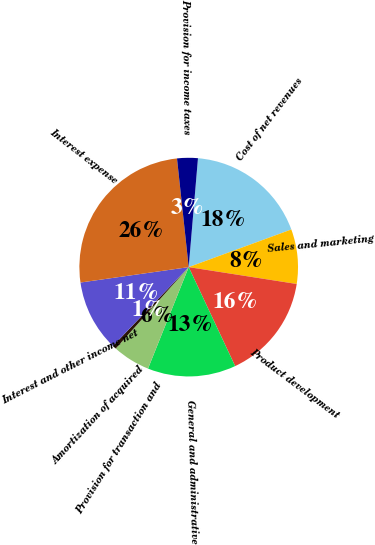<chart> <loc_0><loc_0><loc_500><loc_500><pie_chart><fcel>Cost of net revenues<fcel>Sales and marketing<fcel>Product development<fcel>General and administrative<fcel>Provision for transaction and<fcel>Amortization of acquired<fcel>Interest and other income net<fcel>Interest expense<fcel>Provision for income taxes<nl><fcel>18.05%<fcel>8.06%<fcel>15.55%<fcel>13.05%<fcel>5.56%<fcel>0.56%<fcel>10.56%<fcel>25.54%<fcel>3.06%<nl></chart> 